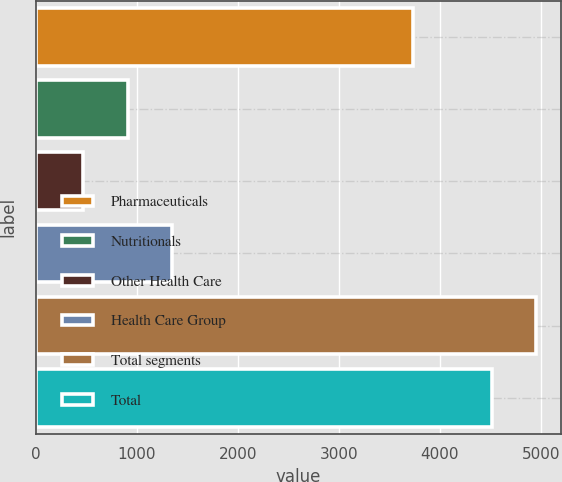Convert chart. <chart><loc_0><loc_0><loc_500><loc_500><bar_chart><fcel>Pharmaceuticals<fcel>Nutritionals<fcel>Other Health Care<fcel>Health Care Group<fcel>Total segments<fcel>Total<nl><fcel>3732<fcel>909.9<fcel>469<fcel>1350.8<fcel>4956.9<fcel>4516<nl></chart> 